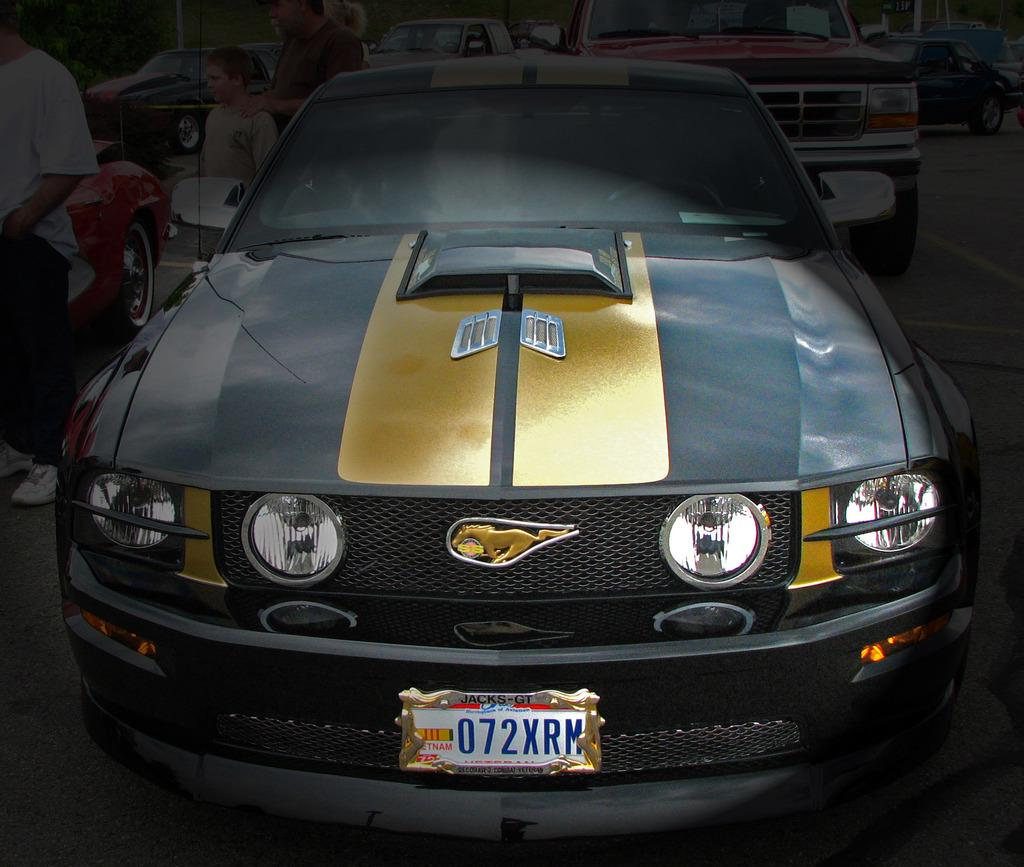What types of objects can be seen in the image? There are vehicles in the image. Can you describe the people in the image? There are people standing on the road in the image. What type of songs can be heard playing from the corn in the image? There is no corn present in the image, and therefore no songs can be heard playing from it. How many pizzas are being served to the people in the image? There is no mention of pizzas in the image, so it cannot be determined how many are being served. 